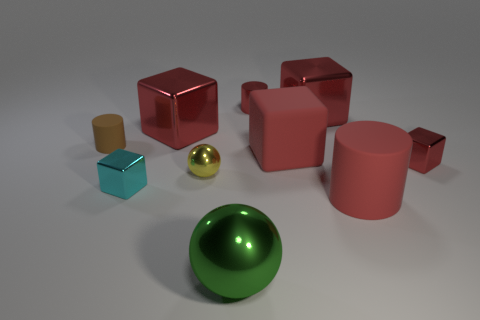What number of other things are there of the same size as the brown rubber thing?
Your response must be concise. 4. Is the material of the big red thing to the left of the tiny metallic sphere the same as the red thing in front of the small cyan object?
Give a very brief answer. No. There is a matte cylinder that is to the right of the large metallic sphere; does it have the same color as the large rubber thing behind the large red matte cylinder?
Keep it short and to the point. Yes. How many tiny red objects are on the left side of the big cylinder?
Provide a succinct answer. 1. How many tiny cylinders are the same material as the green object?
Your answer should be very brief. 1. Is the material of the small block left of the large ball the same as the brown thing?
Provide a succinct answer. No. Are any big yellow metal cylinders visible?
Your answer should be very brief. No. There is a cylinder that is behind the tiny cyan metallic thing and on the right side of the cyan metal block; how big is it?
Ensure brevity in your answer.  Small. Is the number of small spheres to the right of the tiny brown matte cylinder greater than the number of yellow objects that are in front of the big shiny sphere?
Provide a short and direct response. Yes. There is a metal cylinder that is the same color as the rubber cube; what size is it?
Ensure brevity in your answer.  Small. 